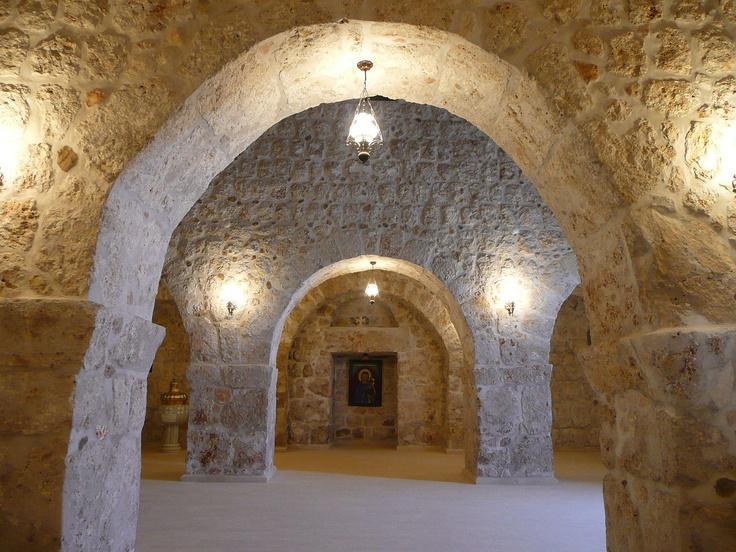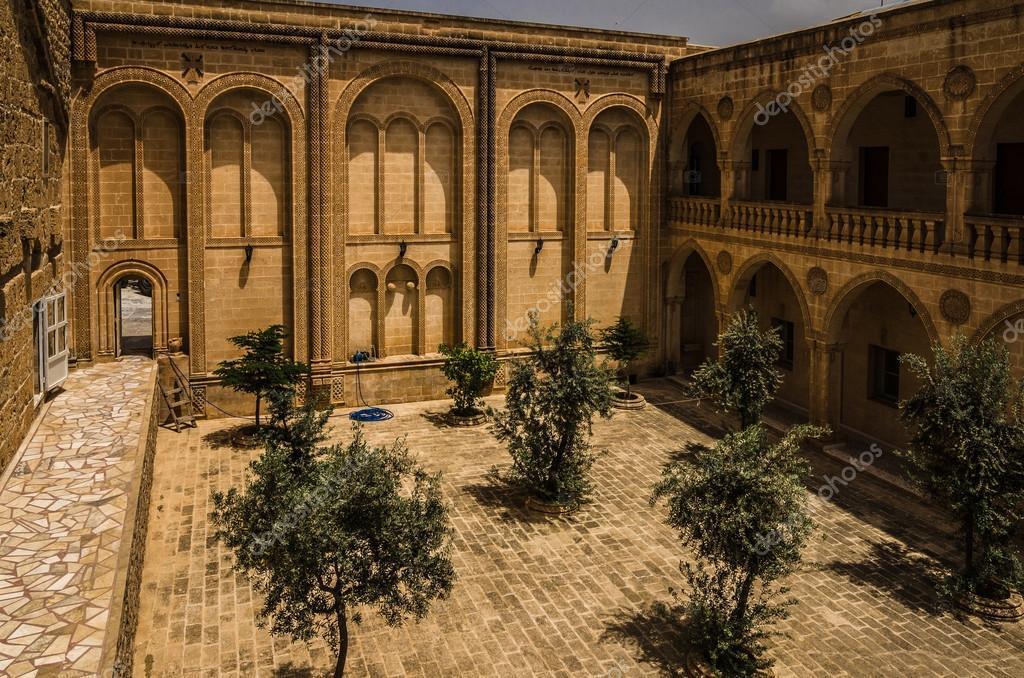The first image is the image on the left, the second image is the image on the right. For the images displayed, is the sentence "A set of stairs lead to an arch in at least one image." factually correct? Answer yes or no. No. 